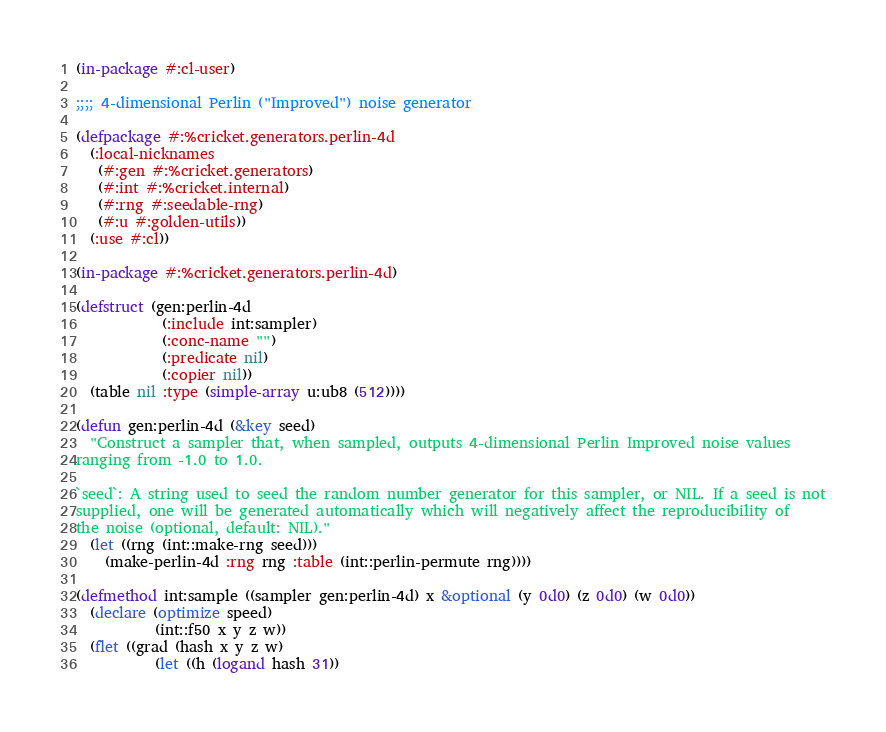Convert code to text. <code><loc_0><loc_0><loc_500><loc_500><_Lisp_>(in-package #:cl-user)

;;;; 4-dimensional Perlin ("Improved") noise generator

(defpackage #:%cricket.generators.perlin-4d
  (:local-nicknames
   (#:gen #:%cricket.generators)
   (#:int #:%cricket.internal)
   (#:rng #:seedable-rng)
   (#:u #:golden-utils))
  (:use #:cl))

(in-package #:%cricket.generators.perlin-4d)

(defstruct (gen:perlin-4d
            (:include int:sampler)
            (:conc-name "")
            (:predicate nil)
            (:copier nil))
  (table nil :type (simple-array u:ub8 (512))))

(defun gen:perlin-4d (&key seed)
  "Construct a sampler that, when sampled, outputs 4-dimensional Perlin Improved noise values
ranging from -1.0 to 1.0.

`seed`: A string used to seed the random number generator for this sampler, or NIL. If a seed is not
supplied, one will be generated automatically which will negatively affect the reproducibility of
the noise (optional, default: NIL)."
  (let ((rng (int::make-rng seed)))
    (make-perlin-4d :rng rng :table (int::perlin-permute rng))))

(defmethod int:sample ((sampler gen:perlin-4d) x &optional (y 0d0) (z 0d0) (w 0d0))
  (declare (optimize speed)
           (int::f50 x y z w))
  (flet ((grad (hash x y z w)
           (let ((h (logand hash 31))</code> 